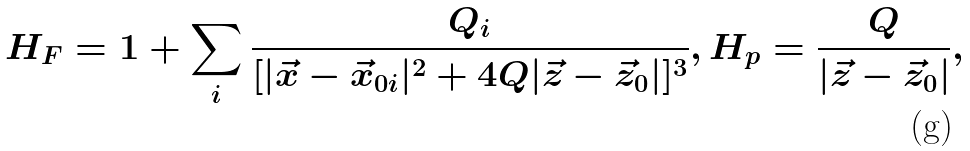<formula> <loc_0><loc_0><loc_500><loc_500>H _ { F } = 1 + \sum _ { i } \frac { Q _ { i } } { [ | \vec { x } - \vec { x } _ { 0 i } | ^ { 2 } + 4 Q | \vec { z } - \vec { z } _ { 0 } | ] ^ { 3 } } , H _ { p } = \frac { Q } { | \vec { z } - \vec { z } _ { 0 } | } ,</formula> 